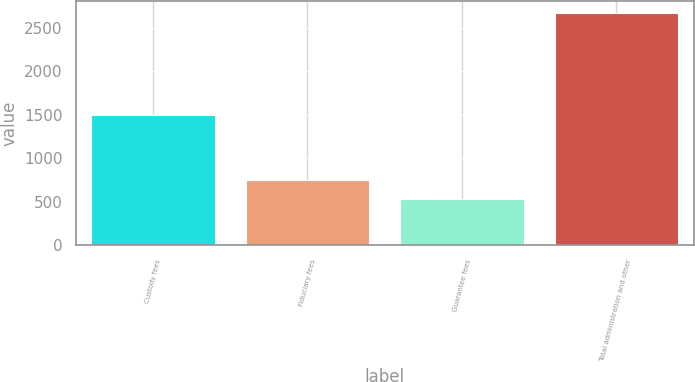Convert chart to OTSL. <chart><loc_0><loc_0><loc_500><loc_500><bar_chart><fcel>Custody fees<fcel>Fiduciary fees<fcel>Guarantee fees<fcel>Total administration and other<nl><fcel>1494<fcel>749.9<fcel>536<fcel>2675<nl></chart> 